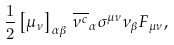Convert formula to latex. <formula><loc_0><loc_0><loc_500><loc_500>\frac { 1 } { 2 } \left [ \mu _ { \nu } \right ] _ { \alpha \beta } \, \overline { \nu ^ { c } } _ { \alpha } \sigma ^ { \mu \nu } \nu _ { \beta } F _ { \mu \nu } ,</formula> 